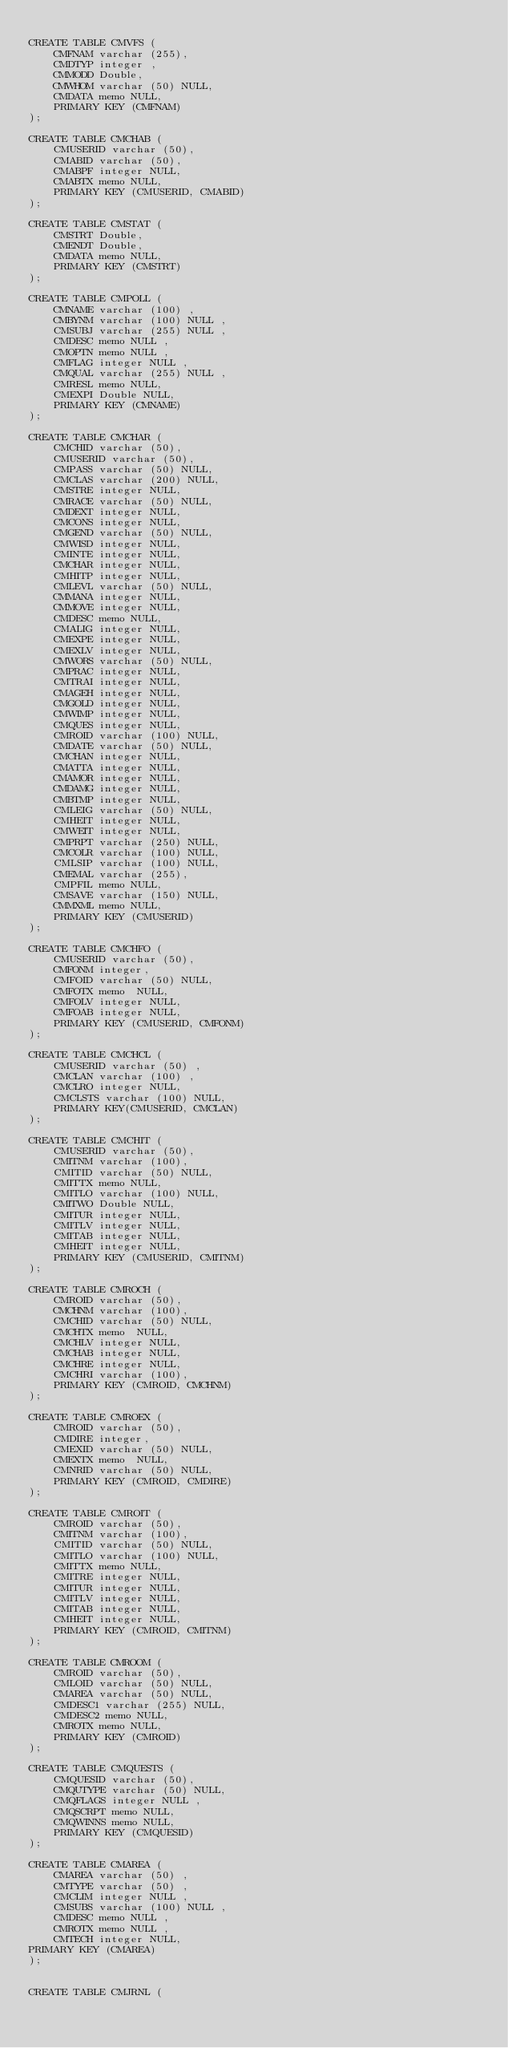<code> <loc_0><loc_0><loc_500><loc_500><_SQL_>
CREATE TABLE CMVFS (
	CMFNAM varchar (255),
	CMDTYP integer ,
	CMMODD Double,
	CMWHOM varchar (50) NULL,
	CMDATA memo NULL,
	PRIMARY KEY (CMFNAM)
);

CREATE TABLE CMCHAB (
	CMUSERID varchar (50),
	CMABID varchar (50),
	CMABPF integer NULL,
	CMABTX memo NULL,
	PRIMARY KEY (CMUSERID, CMABID)
);

CREATE TABLE CMSTAT (
	CMSTRT Double,
	CMENDT Double,
	CMDATA memo NULL,
	PRIMARY KEY (CMSTRT)
);

CREATE TABLE CMPOLL (
	CMNAME varchar (100) ,
	CMBYNM varchar (100) NULL ,
	CMSUBJ varchar (255) NULL ,
	CMDESC memo NULL ,
	CMOPTN memo NULL ,
	CMFLAG integer NULL ,
	CMQUAL varchar (255) NULL ,
	CMRESL memo NULL,
	CMEXPI Double NULL,
	PRIMARY KEY (CMNAME)
);

CREATE TABLE CMCHAR (
	CMCHID varchar (50),
	CMUSERID varchar (50),
	CMPASS varchar (50) NULL,
	CMCLAS varchar (200) NULL,
	CMSTRE integer NULL,
	CMRACE varchar (50) NULL,
	CMDEXT integer NULL,
	CMCONS integer NULL,
	CMGEND varchar (50) NULL,
	CMWISD integer NULL,
	CMINTE integer NULL,
	CMCHAR integer NULL,
	CMHITP integer NULL,
	CMLEVL varchar (50) NULL,
	CMMANA integer NULL,
	CMMOVE integer NULL,
	CMDESC memo NULL,
	CMALIG integer NULL,
	CMEXPE integer NULL,
	CMEXLV integer NULL,
	CMWORS varchar (50) NULL,
	CMPRAC integer NULL,
	CMTRAI integer NULL,
	CMAGEH integer NULL,
	CMGOLD integer NULL,
	CMWIMP integer NULL,
	CMQUES integer NULL,
	CMROID varchar (100) NULL,
	CMDATE varchar (50) NULL,
	CMCHAN integer NULL,
	CMATTA integer NULL,
	CMAMOR integer NULL,
	CMDAMG integer NULL,
	CMBTMP integer NULL,
	CMLEIG varchar (50) NULL,
	CMHEIT integer NULL,
	CMWEIT integer NULL,
	CMPRPT varchar (250) NULL,
	CMCOLR varchar (100) NULL,
	CMLSIP varchar (100) NULL,
	CMEMAL varchar (255),
	CMPFIL memo NULL,
	CMSAVE varchar (150) NULL,
	CMMXML memo NULL,
	PRIMARY KEY (CMUSERID)
);

CREATE TABLE CMCHFO (
	CMUSERID varchar (50),
	CMFONM integer,
	CMFOID varchar (50) NULL,
	CMFOTX memo  NULL,
	CMFOLV integer NULL,
	CMFOAB integer NULL,
	PRIMARY KEY (CMUSERID, CMFONM)
);

CREATE TABLE CMCHCL (
	CMUSERID varchar (50) ,
	CMCLAN varchar (100) ,
	CMCLRO integer NULL,
	CMCLSTS varchar (100) NULL,
	PRIMARY KEY(CMUSERID, CMCLAN)
);

CREATE TABLE CMCHIT (
	CMUSERID varchar (50),
	CMITNM varchar (100),
	CMITID varchar (50) NULL,
	CMITTX memo NULL,
	CMITLO varchar (100) NULL,
	CMITWO Double NULL,
	CMITUR integer NULL,
	CMITLV integer NULL,
	CMITAB integer NULL,
	CMHEIT integer NULL,
	PRIMARY KEY (CMUSERID, CMITNM)
);

CREATE TABLE CMROCH (
	CMROID varchar (50),
	CMCHNM varchar (100),
	CMCHID varchar (50) NULL,
	CMCHTX memo  NULL,
	CMCHLV integer NULL,
	CMCHAB integer NULL,
	CMCHRE integer NULL,
	CMCHRI varchar (100),
	PRIMARY KEY (CMROID, CMCHNM)
);

CREATE TABLE CMROEX (
	CMROID varchar (50),
	CMDIRE integer,
	CMEXID varchar (50) NULL,
	CMEXTX memo  NULL,
	CMNRID varchar (50) NULL,
	PRIMARY KEY (CMROID, CMDIRE)
);

CREATE TABLE CMROIT (
	CMROID varchar (50),
	CMITNM varchar (100),
	CMITID varchar (50) NULL,
	CMITLO varchar (100) NULL,
	CMITTX memo NULL,
	CMITRE integer NULL,
	CMITUR integer NULL,
	CMITLV integer NULL,
	CMITAB integer NULL,
	CMHEIT integer NULL,
	PRIMARY KEY (CMROID, CMITNM)
);

CREATE TABLE CMROOM (
	CMROID varchar (50),
	CMLOID varchar (50) NULL,
	CMAREA varchar (50) NULL,
	CMDESC1 varchar (255) NULL,
	CMDESC2 memo NULL,
	CMROTX memo NULL,
	PRIMARY KEY (CMROID)
);

CREATE TABLE CMQUESTS (
	CMQUESID varchar (50),
	CMQUTYPE varchar (50) NULL,
	CMQFLAGS integer NULL ,
	CMQSCRPT memo NULL,
	CMQWINNS memo NULL,
	PRIMARY KEY (CMQUESID)
);

CREATE TABLE CMAREA (
	CMAREA varchar (50) ,
	CMTYPE varchar (50) ,
	CMCLIM integer NULL ,
	CMSUBS varchar (100) NULL ,
	CMDESC memo NULL ,
	CMROTX memo NULL , 
	CMTECH integer NULL,
PRIMARY KEY (CMAREA)
);


CREATE TABLE CMJRNL (</code> 